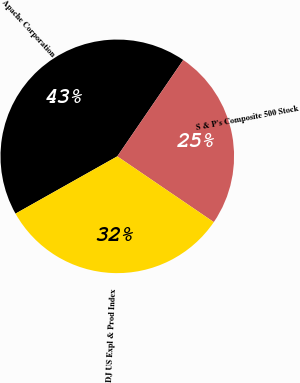Convert chart to OTSL. <chart><loc_0><loc_0><loc_500><loc_500><pie_chart><fcel>Apache Corporation<fcel>S & P's Composite 500 Stock<fcel>DJ US Expl & Prod Index<nl><fcel>42.71%<fcel>24.97%<fcel>32.32%<nl></chart> 